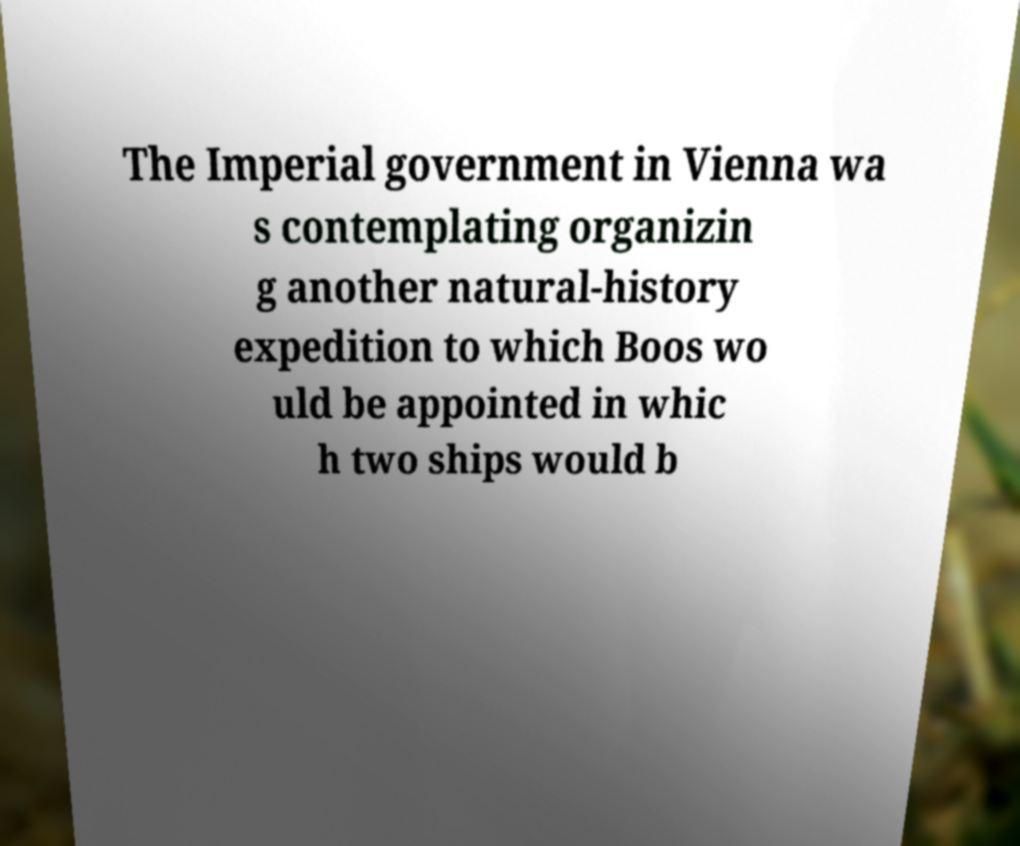Can you read and provide the text displayed in the image?This photo seems to have some interesting text. Can you extract and type it out for me? The Imperial government in Vienna wa s contemplating organizin g another natural-history expedition to which Boos wo uld be appointed in whic h two ships would b 